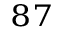Convert formula to latex. <formula><loc_0><loc_0><loc_500><loc_500>^ { 8 7 }</formula> 